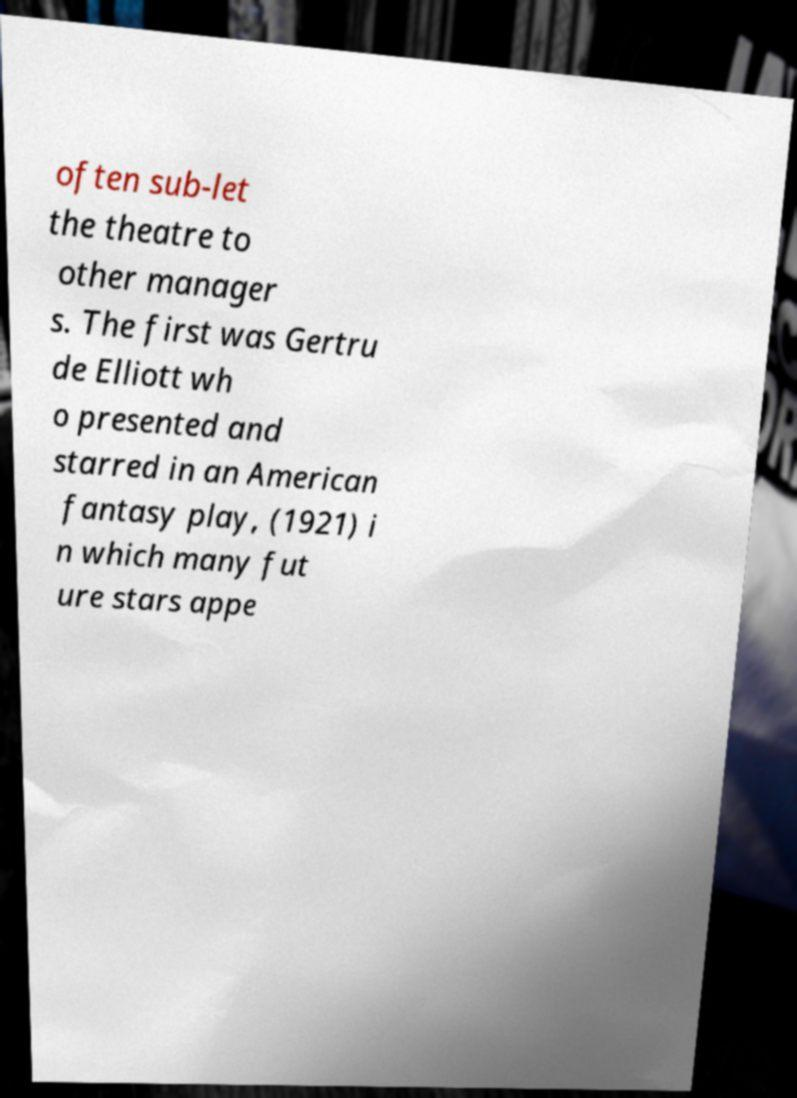What messages or text are displayed in this image? I need them in a readable, typed format. often sub-let the theatre to other manager s. The first was Gertru de Elliott wh o presented and starred in an American fantasy play, (1921) i n which many fut ure stars appe 